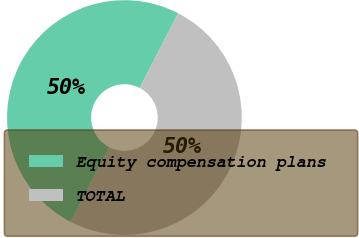Convert chart to OTSL. <chart><loc_0><loc_0><loc_500><loc_500><pie_chart><fcel>Equity compensation plans<fcel>TOTAL<nl><fcel>50.0%<fcel>50.0%<nl></chart> 